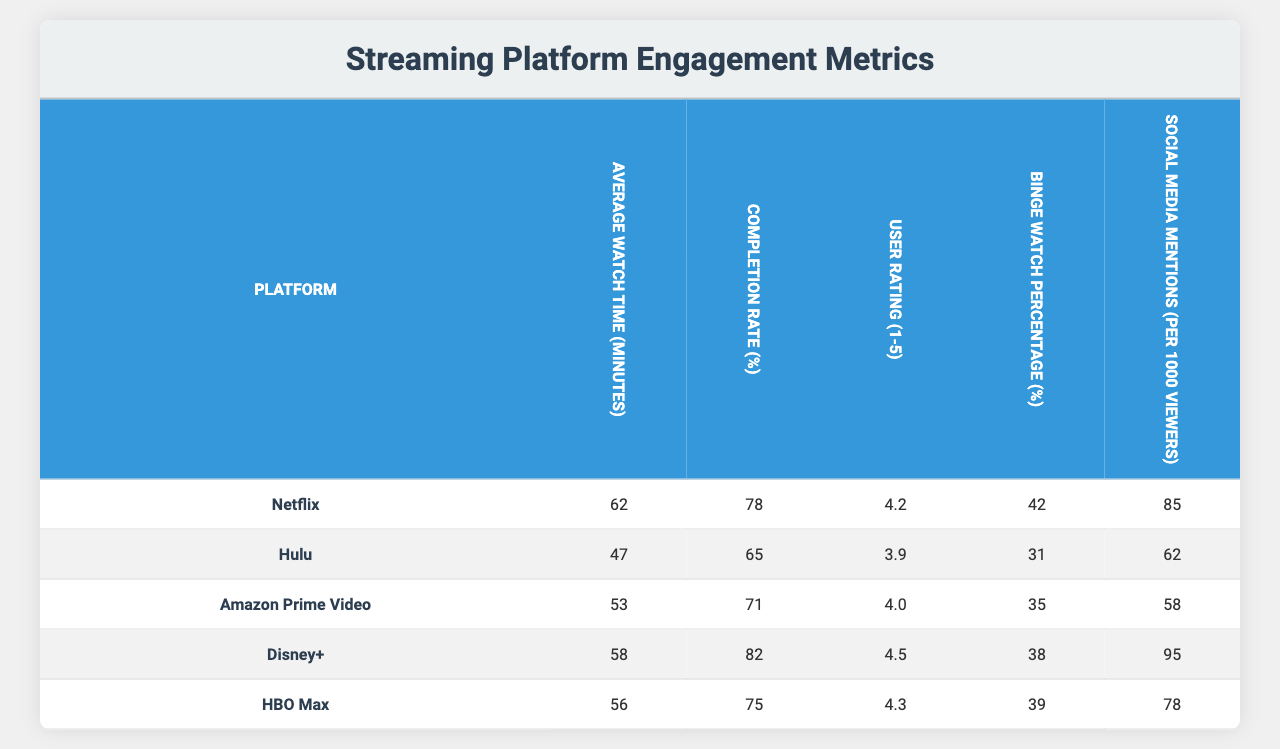What is the highest average watch time among the streaming platforms? Looking at the "Average Watch Time (minutes)" column, Netflix has the highest value at 62 minutes compared to other platforms.
Answer: 62 Which platform has the highest completion rate? By examining the "Completion Rate (%)" column, Disney+ has the highest completion rate at 82%.
Answer: 82% What is the user rating for HBO Max? The "User Rating (1-5)" column shows that HBO Max has a user rating of 4.3.
Answer: 4.3 How many minutes less on average do viewers watch on Hulu compared to Netflix? The average watch time for Hulu is 47 minutes and for Netflix is 62 minutes. The difference is 62 - 47 = 15 minutes.
Answer: 15 minutes Which platform has the lowest binge watch percentage? The "Binge Watch Percentage (%)" column indicates that Hulu has the lowest percentage at 31%.
Answer: 31% True or False: Amazon Prime Video has a higher completion rate than HBO Max. Amazon Prime Video has a completion rate of 71%, while HBO Max has 75%, therefore this statement is false.
Answer: False What is the average user rating across all platforms? Adding the user ratings for all platforms gives us (4.2 + 3.9 + 4.0 + 4.5 + 4.3) = 20.9. Dividing by 5 (the number of platforms) results in an average of 20.9 / 5 = 4.18.
Answer: 4.18 Which platform has the most social media mentions per 1000 viewers? The "Social Media Mentions (per 1000 viewers)" column shows that Disney+ has the highest at 95 mentions.
Answer: 95 If we combine the average watch times for Netflix and HBO Max, what is the total watch time? The average watch times are 62 minutes for Netflix and 56 minutes for HBO Max. Summing these gives us 62 + 56 = 118 minutes.
Answer: 118 minutes Which platforms have a user rating of 4 or higher? The platforms with a user rating of 4 or higher are Netflix (4.2), Amazon Prime Video (4.0), Disney+ (4.5), and HBO Max (4.3). Hulu is below this threshold.
Answer: Netflix, Amazon Prime Video, Disney+, HBO Max 